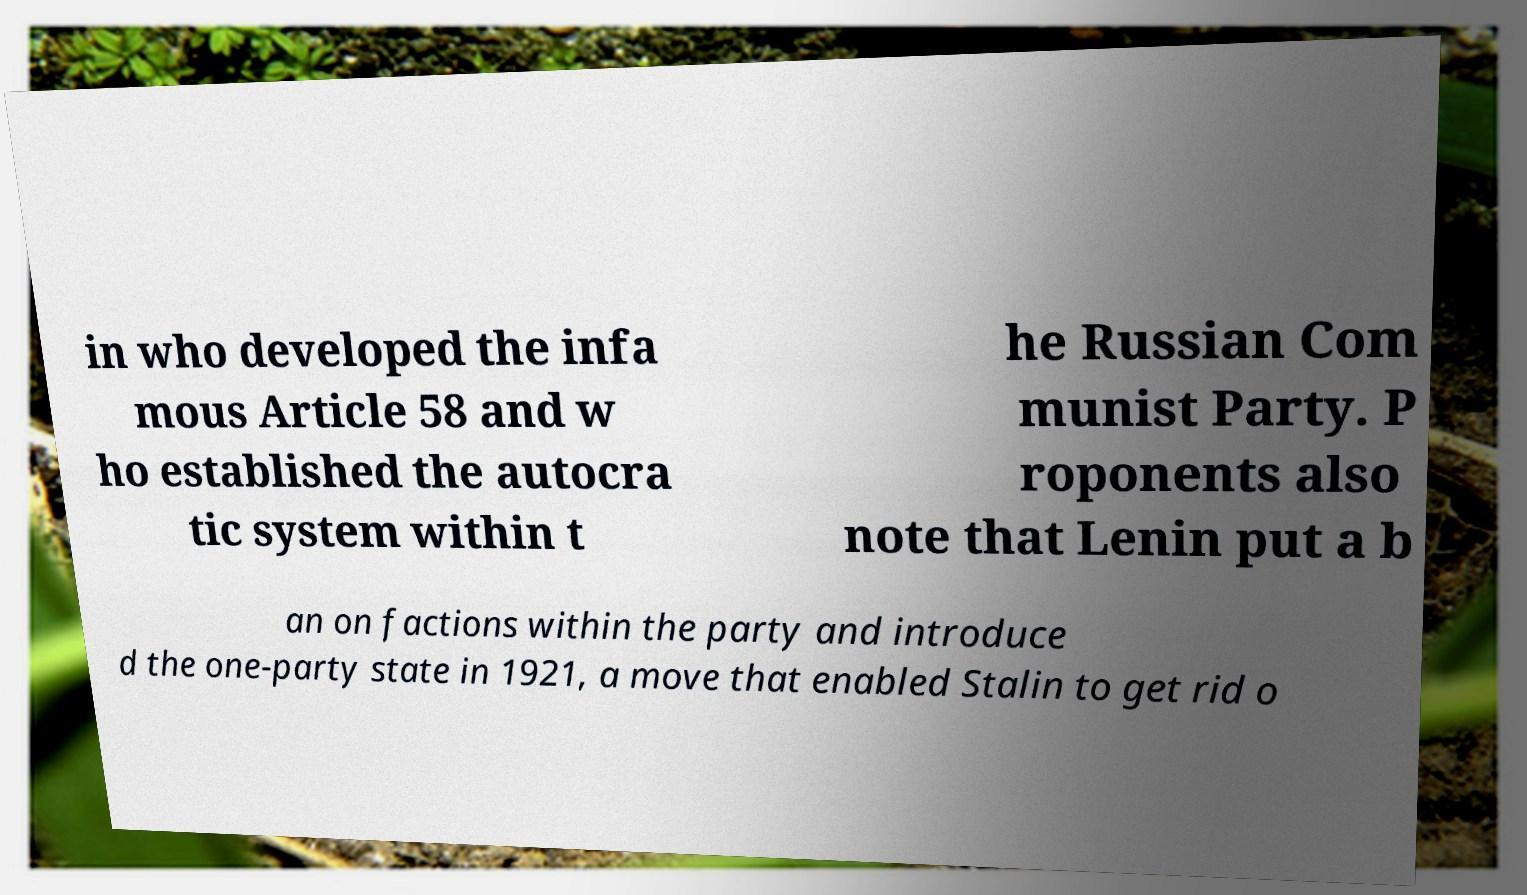Please read and relay the text visible in this image. What does it say? in who developed the infa mous Article 58 and w ho established the autocra tic system within t he Russian Com munist Party. P roponents also note that Lenin put a b an on factions within the party and introduce d the one-party state in 1921, a move that enabled Stalin to get rid o 